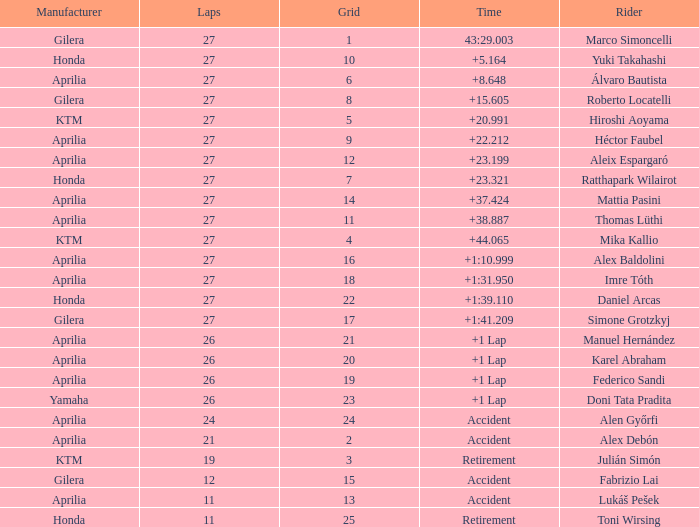Which Manufacturer has a Time of accident and a Grid greater than 15? Aprilia. 